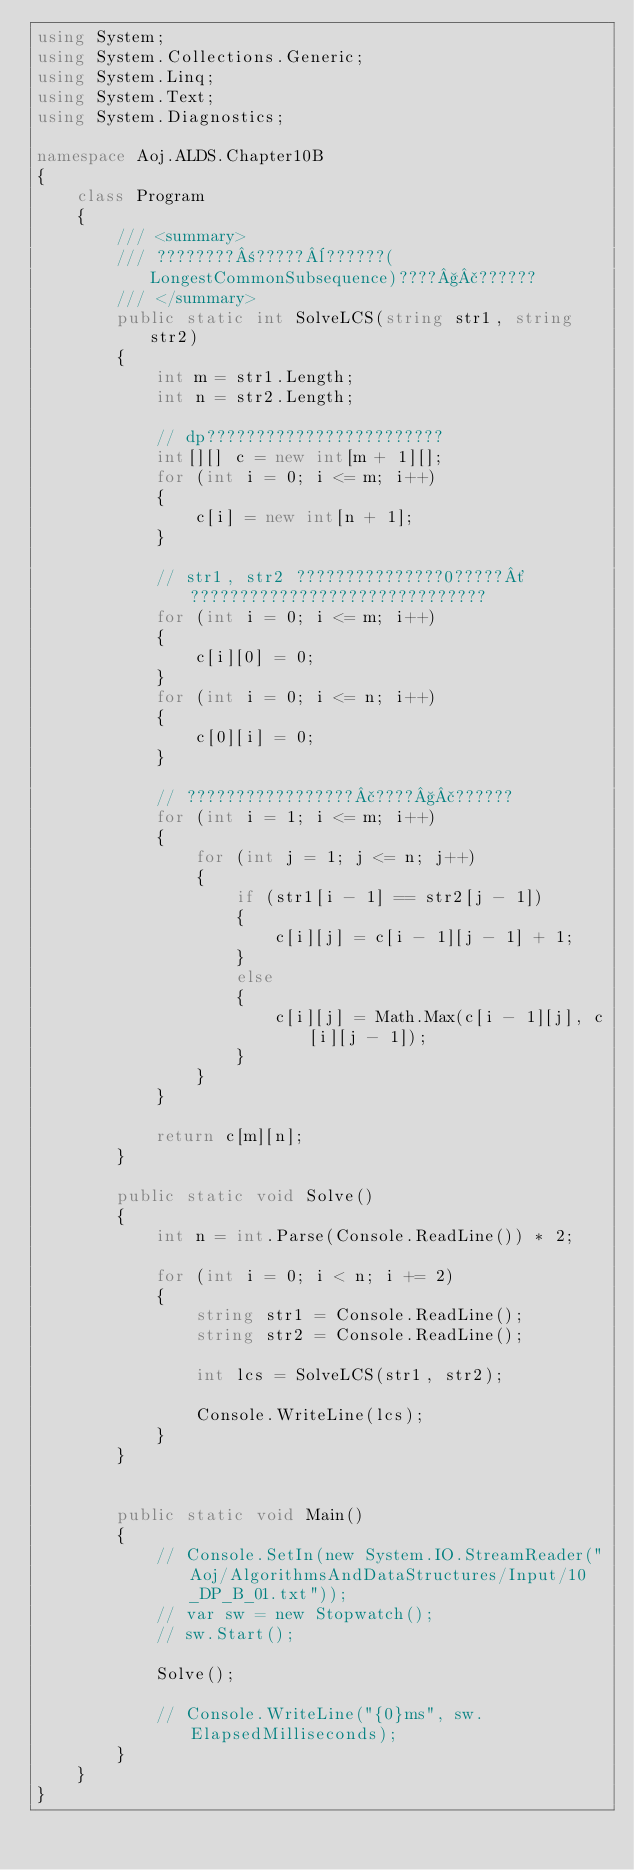<code> <loc_0><loc_0><loc_500><loc_500><_C#_>using System;
using System.Collections.Generic;
using System.Linq;
using System.Text;
using System.Diagnostics;

namespace Aoj.ALDS.Chapter10B
{
    class Program
    {
        /// <summary>
        /// ????????±?????¨??????(LongestCommonSubsequence)????§£??????
        /// </summary>
        public static int SolveLCS(string str1, string str2)
        {
            int m = str1.Length;
            int n = str2.Length;

            // dp????????????????????????
            int[][] c = new int[m + 1][];
            for (int i = 0; i <= m; i++)
            {
                c[i] = new int[n + 1];
            }

            // str1, str2 ???????????????0?????´??????????????????????????????
            for (int i = 0; i <= m; i++)
            {
                c[i][0] = 0;
            }
            for (int i = 0; i <= n; i++)
            {
                c[0][i] = 0;
            }

            // ?????????????????£????§£??????
            for (int i = 1; i <= m; i++)
            {
                for (int j = 1; j <= n; j++)
                {
                    if (str1[i - 1] == str2[j - 1])
                    {
                        c[i][j] = c[i - 1][j - 1] + 1;
                    }
                    else
                    {
                        c[i][j] = Math.Max(c[i - 1][j], c[i][j - 1]);
                    }
                }
            }

            return c[m][n];
        }

        public static void Solve()
        {
            int n = int.Parse(Console.ReadLine()) * 2;

            for (int i = 0; i < n; i += 2)
            {
                string str1 = Console.ReadLine();
                string str2 = Console.ReadLine();

                int lcs = SolveLCS(str1, str2);

                Console.WriteLine(lcs);
            }
        }


        public static void Main()
        {
            // Console.SetIn(new System.IO.StreamReader("Aoj/AlgorithmsAndDataStructures/Input/10_DP_B_01.txt"));
            // var sw = new Stopwatch();
            // sw.Start();

            Solve();

            // Console.WriteLine("{0}ms", sw.ElapsedMilliseconds);
        }
    }
}</code> 